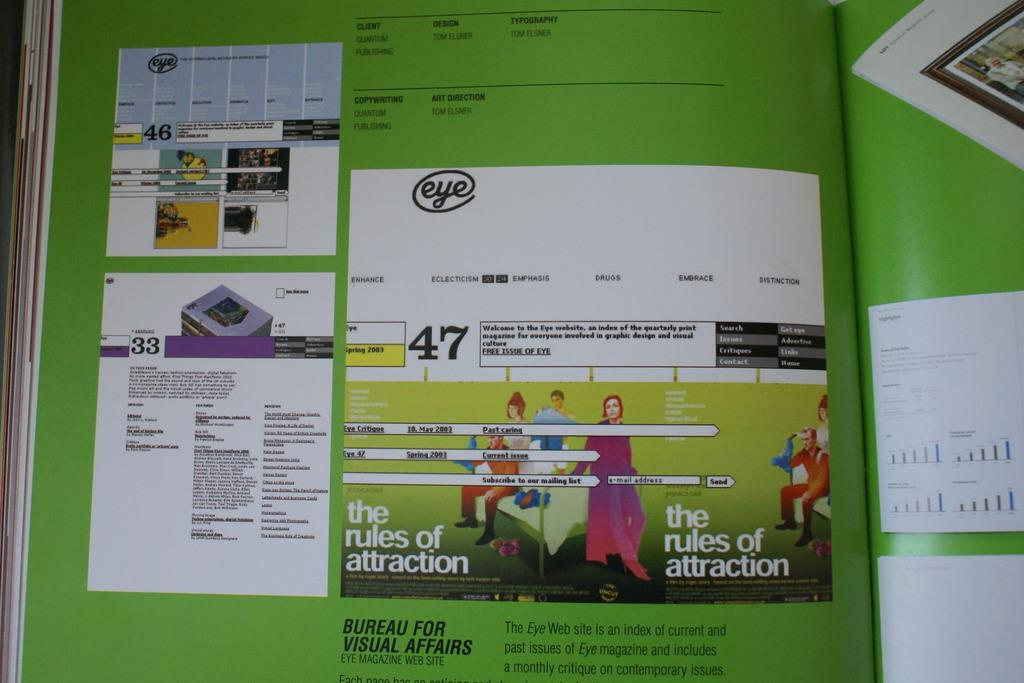<image>
Relay a brief, clear account of the picture shown. The inside of a book turned to a page about the rules of attraction. 